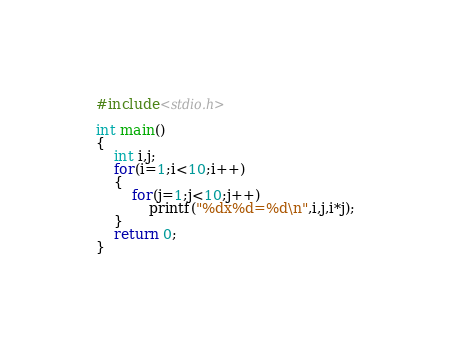<code> <loc_0><loc_0><loc_500><loc_500><_C_>#include<stdio.h>

int main()
{
	int i,j;
	for(i=1;i<10;i++)
	{
		for(j=1;j<10;j++)
			printf("%dx%d=%d\n",i,j,i*j);
	}
	return 0;
}</code> 